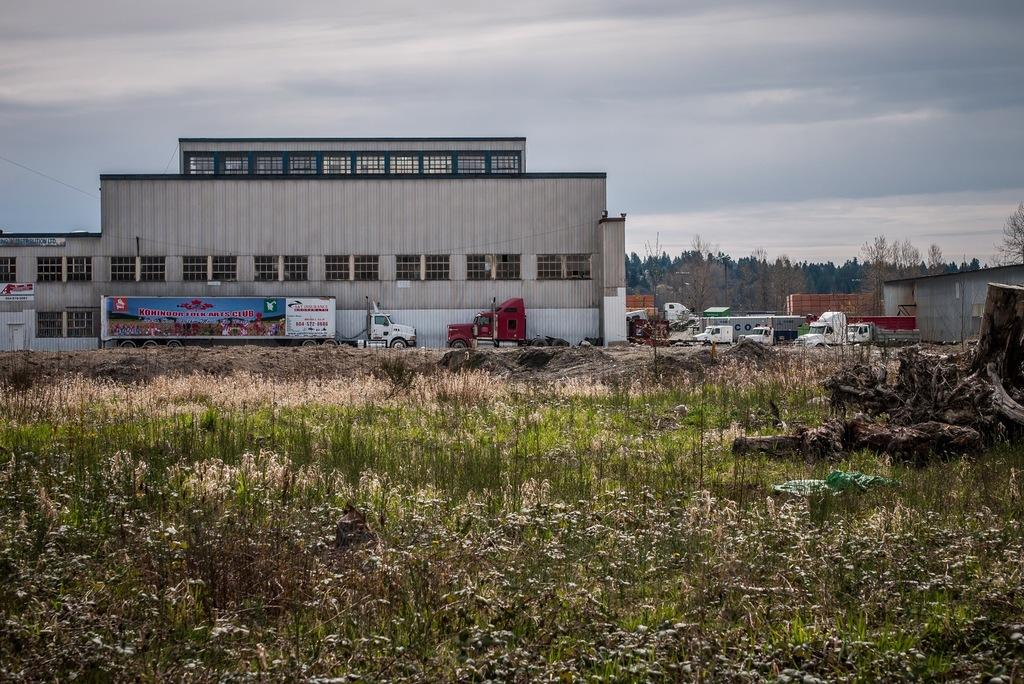What is located in the foreground of the image? There are plants and a tree trunk in the foreground of the image. What can be seen in the middle of the image? There are trees, trucks, and buildings in the middle of the image. What is visible at the top of the image? The sky is visible at the top of the image. What type of bun can be seen on the tree trunk in the image? There is no bun present on the tree trunk in the image. What type of sand can be seen in the middle of the image? There is no sand present in the image; it features trees, trucks, and buildings. 